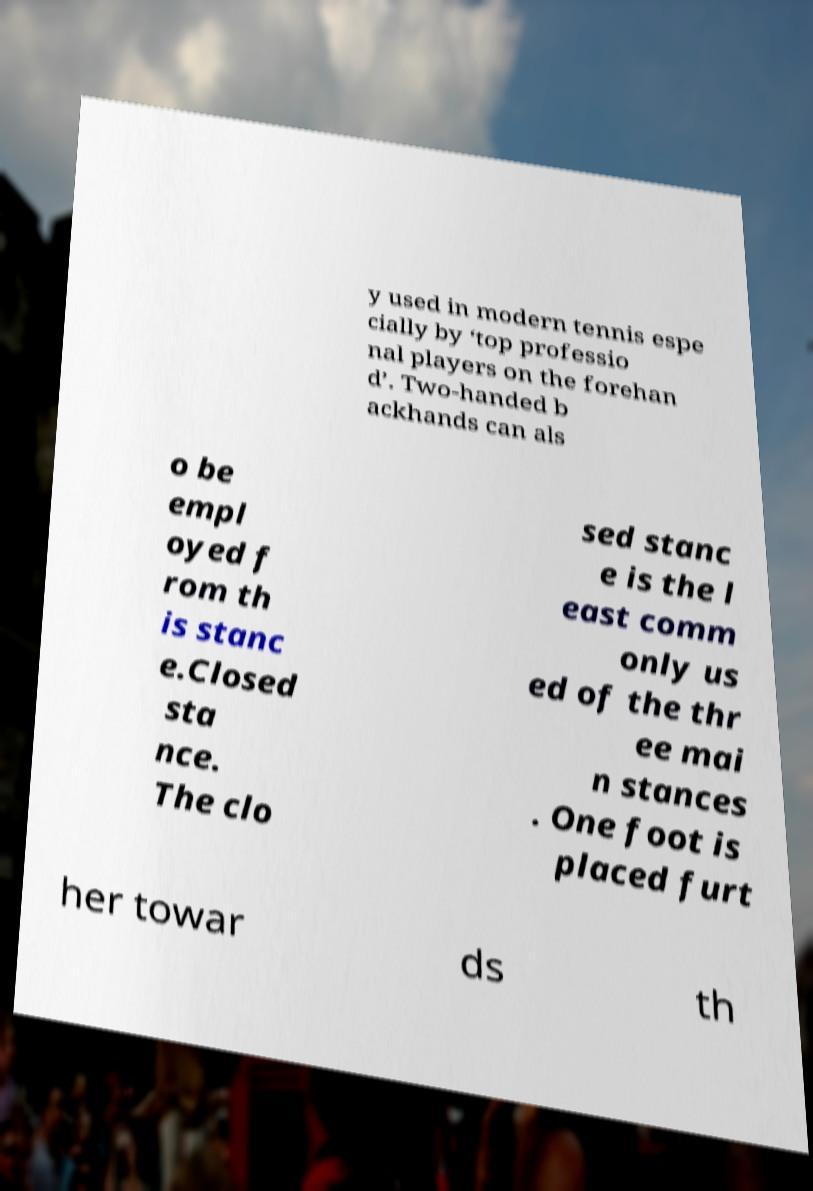Can you read and provide the text displayed in the image?This photo seems to have some interesting text. Can you extract and type it out for me? y used in modern tennis espe cially by ‘top professio nal players on the forehan d’. Two-handed b ackhands can als o be empl oyed f rom th is stanc e.Closed sta nce. The clo sed stanc e is the l east comm only us ed of the thr ee mai n stances . One foot is placed furt her towar ds th 